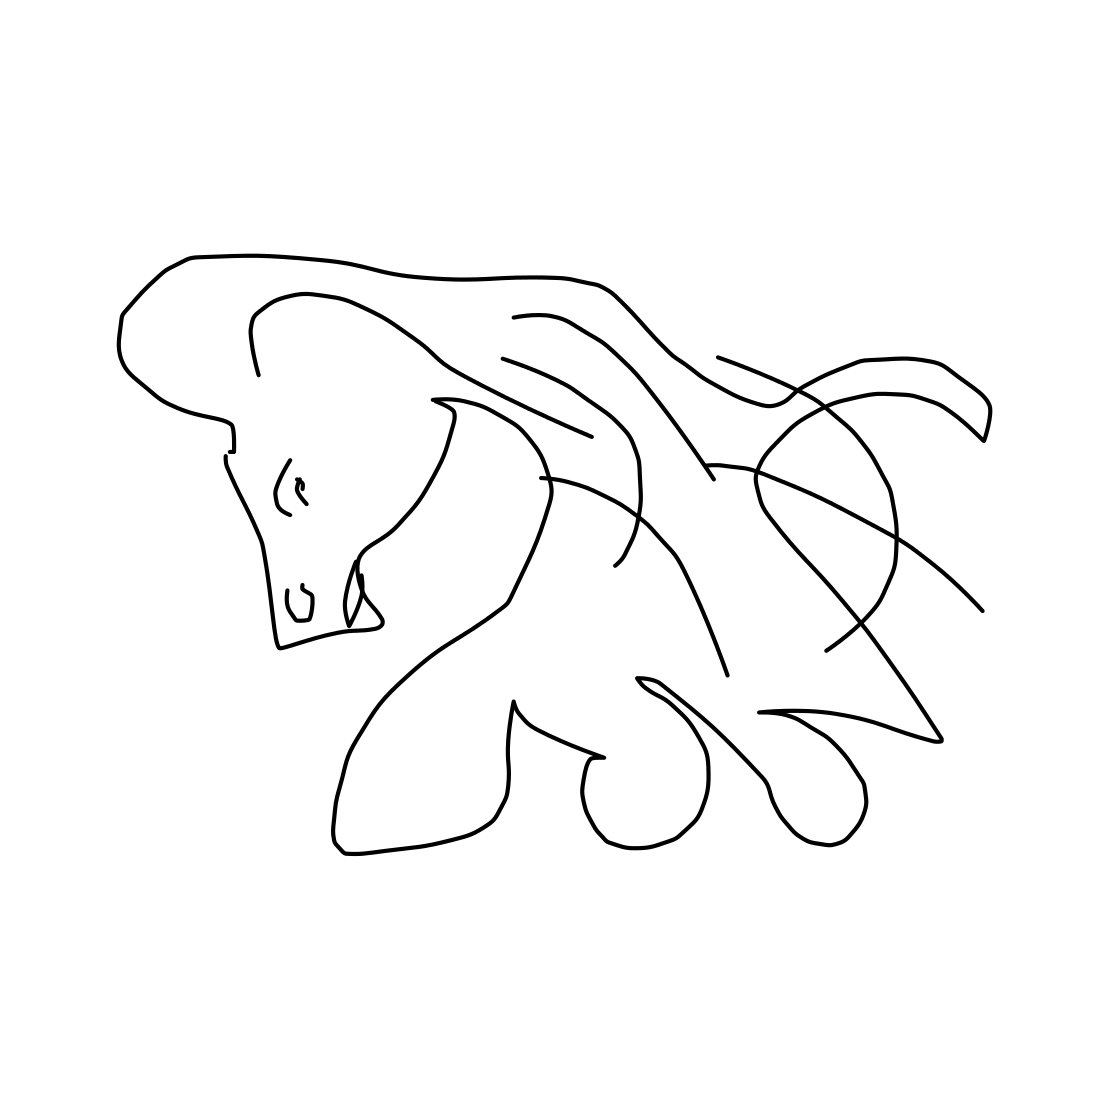In the scene, is a horse in it? Yes, the image depicts a stylized representation of a horse, characterized by flowing lines and a simplified form that captures the essence of the animal’s figure. 